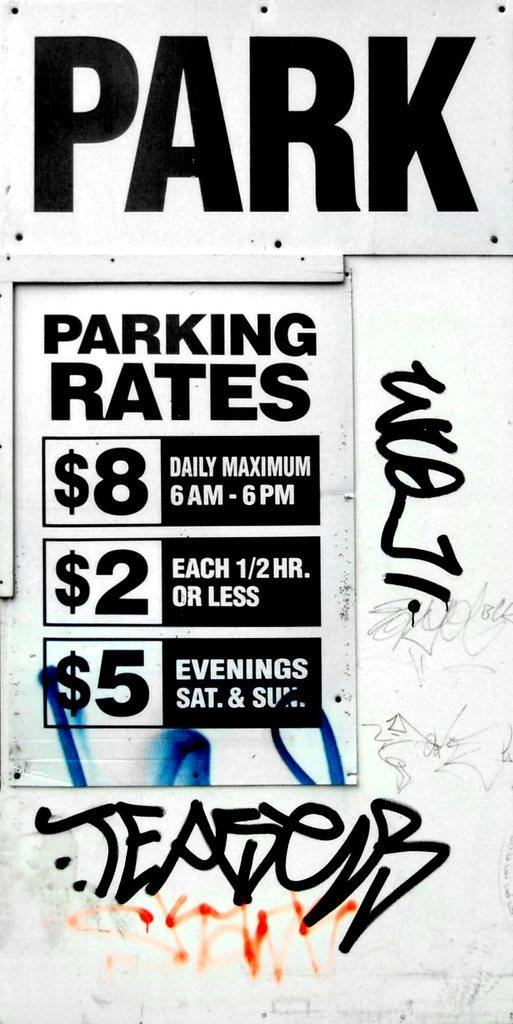<image>
Create a compact narrative representing the image presented. Signs displaying the price of parking, littered with graffiti. 